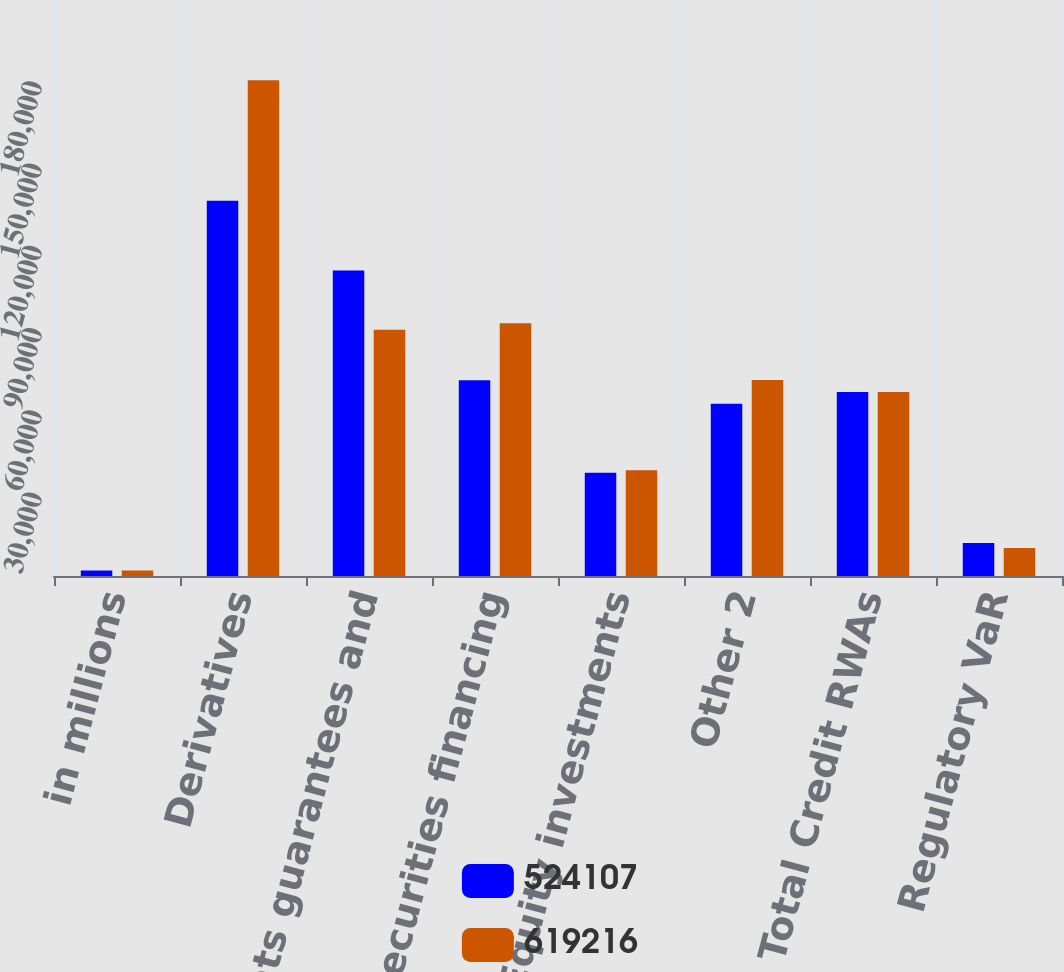Convert chart to OTSL. <chart><loc_0><loc_0><loc_500><loc_500><stacked_bar_chart><ecel><fcel>in millions<fcel>Derivatives<fcel>Commitments guarantees and<fcel>Securities financing<fcel>Equity investments<fcel>Other 2<fcel>Total Credit RWAs<fcel>Regulatory VaR<nl><fcel>524107<fcel>2015<fcel>136841<fcel>111391<fcel>71392<fcel>37687<fcel>62807<fcel>67099.5<fcel>12000<nl><fcel>619216<fcel>2014<fcel>180771<fcel>89783<fcel>92116<fcel>38526<fcel>71499<fcel>67099.5<fcel>10238<nl></chart> 